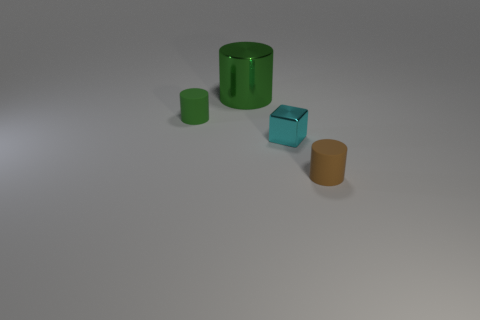Are there any other things that have the same size as the green metal cylinder?
Make the answer very short. No. Are there any cubes made of the same material as the brown cylinder?
Offer a terse response. No. Does the cyan metal thing have the same shape as the rubber object in front of the cyan metal cube?
Your response must be concise. No. Are there any large green metal cylinders behind the small brown thing?
Ensure brevity in your answer.  Yes. How many other small matte objects have the same shape as the tiny brown object?
Provide a short and direct response. 1. Does the cube have the same material as the cylinder in front of the small green thing?
Give a very brief answer. No. How many green cylinders are there?
Your answer should be compact. 2. How big is the metallic cylinder that is behind the small metallic thing?
Provide a succinct answer. Large. How many yellow metallic objects have the same size as the brown thing?
Give a very brief answer. 0. There is a object that is both behind the small brown cylinder and in front of the tiny green rubber cylinder; what material is it?
Ensure brevity in your answer.  Metal. 